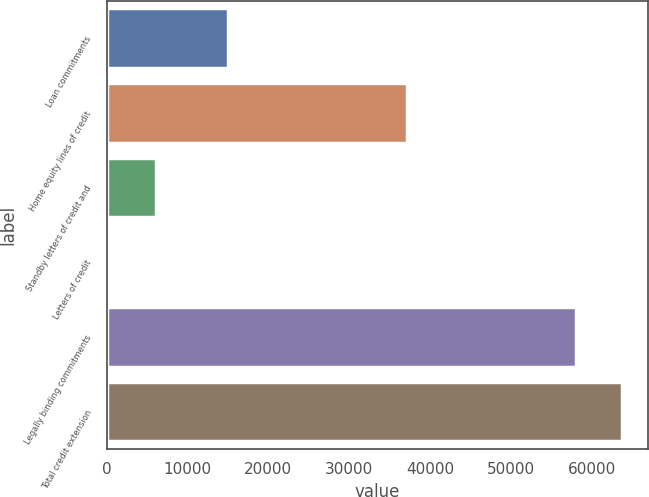Convert chart to OTSL. <chart><loc_0><loc_0><loc_500><loc_500><bar_chart><fcel>Loan commitments<fcel>Home equity lines of credit<fcel>Standby letters of credit and<fcel>Letters of credit<fcel>Legally binding commitments<fcel>Total credit extension<nl><fcel>15009<fcel>37066<fcel>6141<fcel>383<fcel>57963<fcel>63721<nl></chart> 